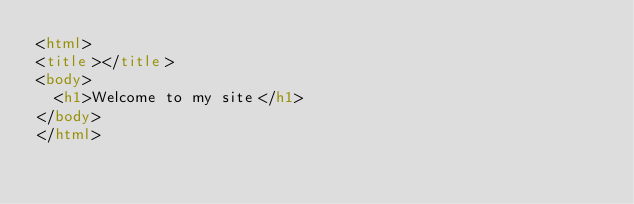<code> <loc_0><loc_0><loc_500><loc_500><_HTML_><html>
<title></title>
<body>
  <h1>Welcome to my site</h1>
</body>
</html>
</code> 